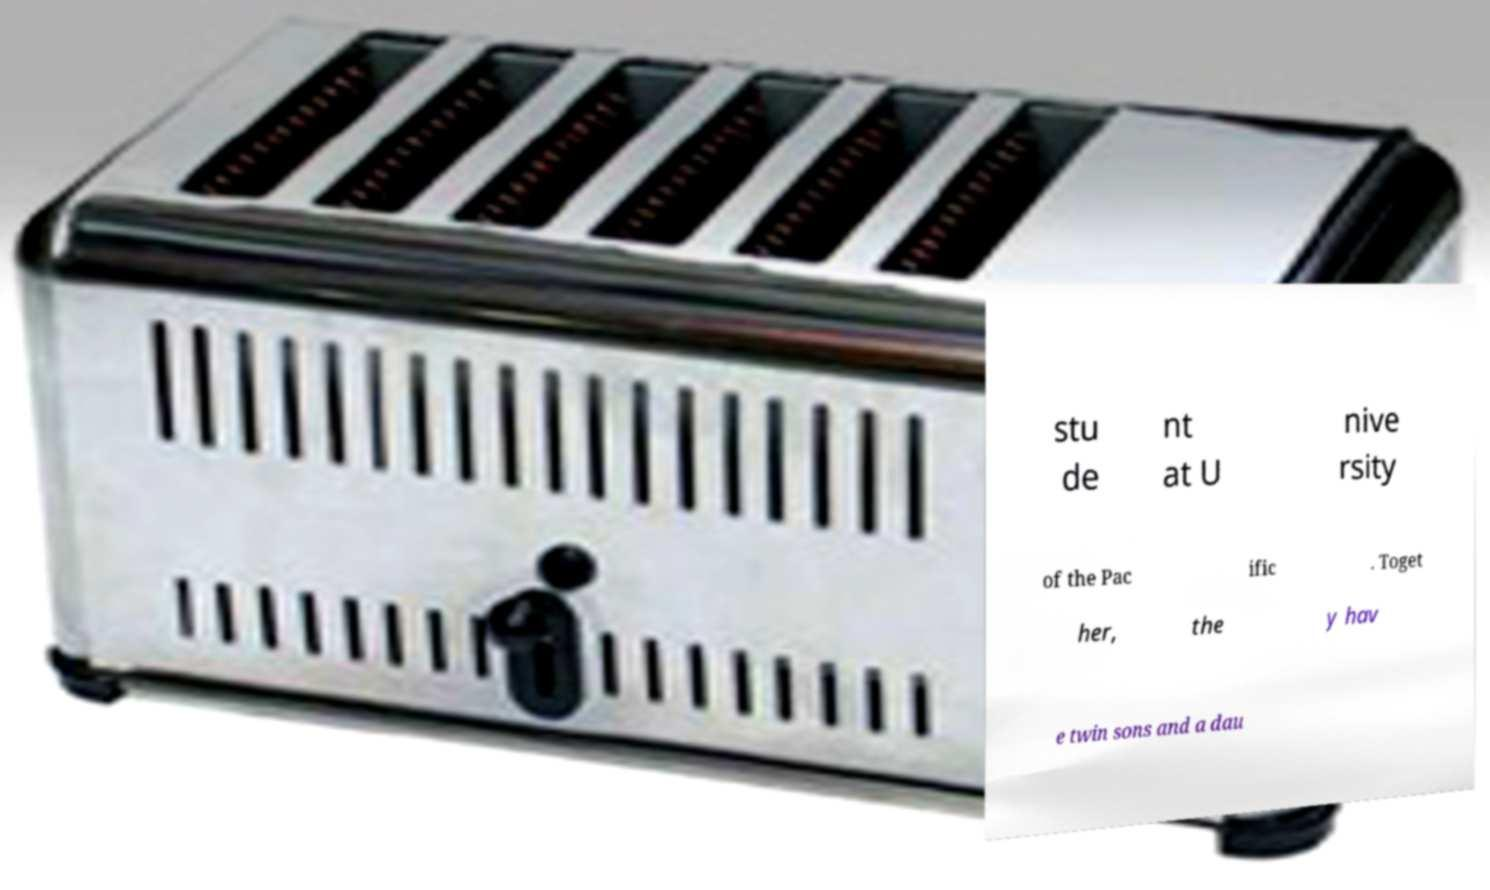Can you accurately transcribe the text from the provided image for me? stu de nt at U nive rsity of the Pac ific . Toget her, the y hav e twin sons and a dau 